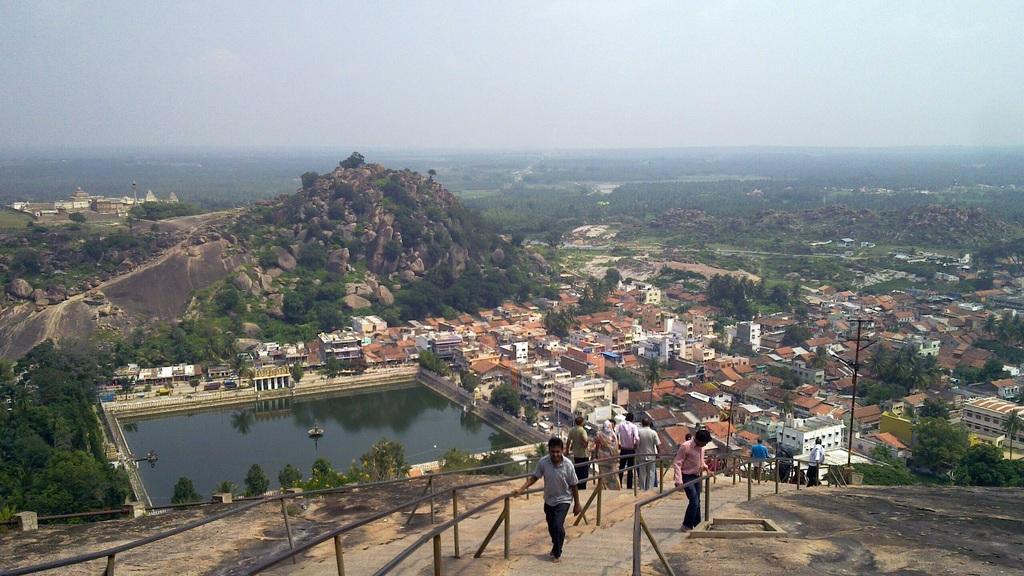Could you give a brief overview of what you see in this image? There are people, buildings and water in the foreground area of the image, it seems like mountains, greenery and the sky in the background. 